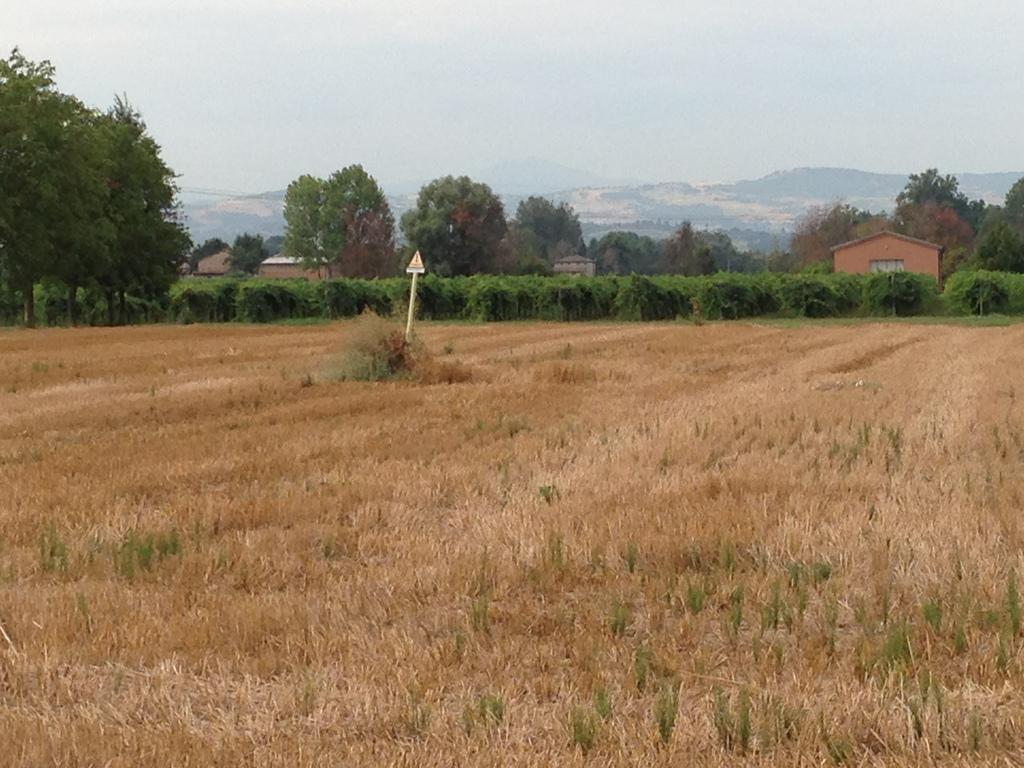What is located in the center of the image? There are trees in the center of the image. What type of vegetation is at the bottom of the image? There is grass at the bottom of the image. Can you describe the sign board visible in the image? Yes, there is a sign board visible in the image. What structures can be seen in the background of the image? There are sheds in the background of the image. What natural features are visible in the background of the image? There are hills and the sky visible in the background of the image. How many boys are playing with clover in the image? There are no boys or clover present in the image. What type of surprise can be seen in the image? There is no surprise visible in the image. 